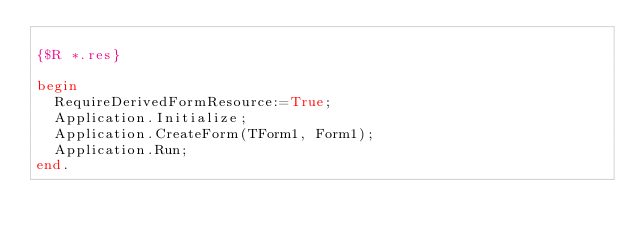<code> <loc_0><loc_0><loc_500><loc_500><_Pascal_>
{$R *.res}

begin
  RequireDerivedFormResource:=True;
  Application.Initialize;
  Application.CreateForm(TForm1, Form1);
  Application.Run;
end.

</code> 